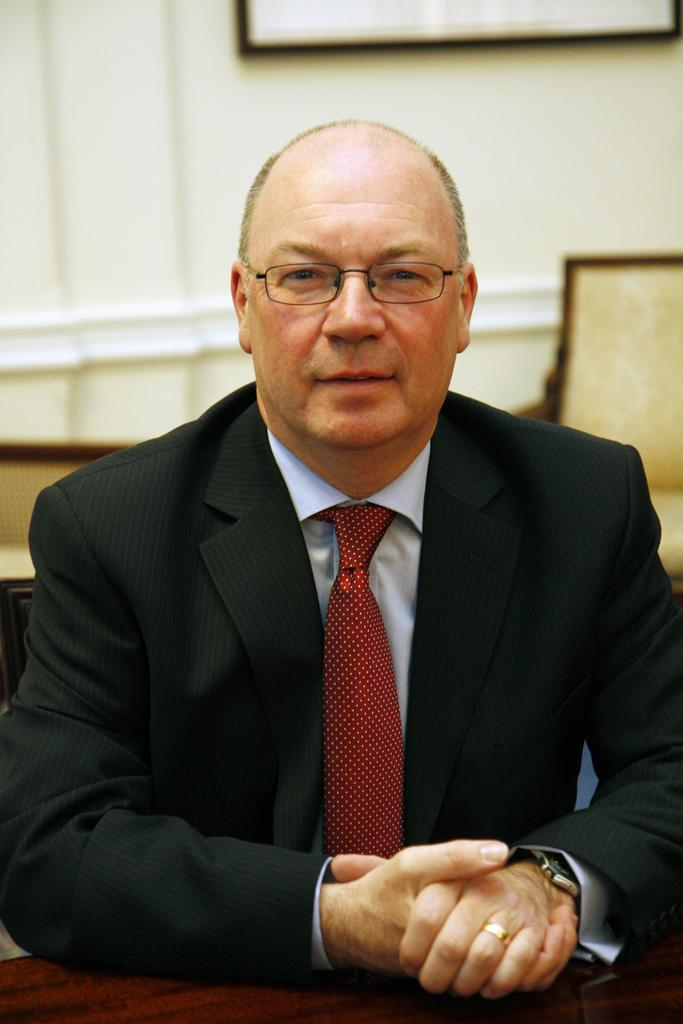What is the person in the image doing? There is a person sitting in the image. What type of furniture is visible in the image? There are chairs in the image. What can be seen attached to the wall in the image? There is a board attached to the wall in the image. What type of advertisement is displayed on the railway in the image? There is no railway or advertisement present in the image. 